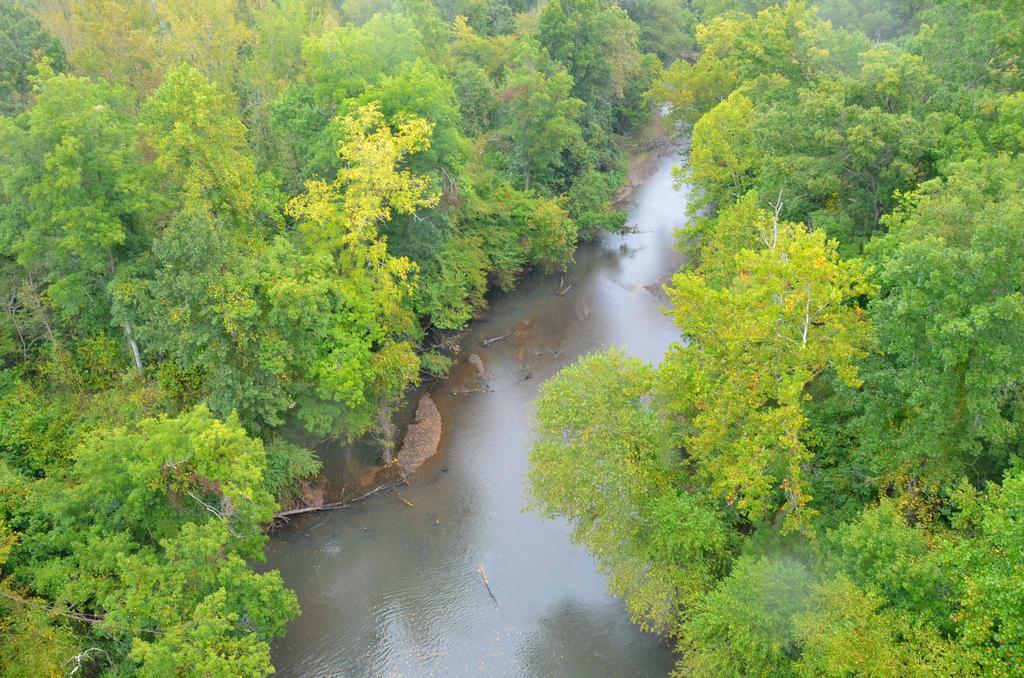Could you give a brief overview of what you see in this image? In this picture we can see water and trees. 